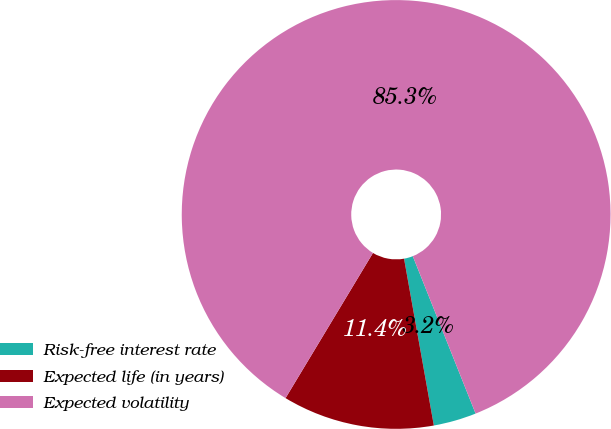Convert chart to OTSL. <chart><loc_0><loc_0><loc_500><loc_500><pie_chart><fcel>Risk-free interest rate<fcel>Expected life (in years)<fcel>Expected volatility<nl><fcel>3.23%<fcel>11.44%<fcel>85.33%<nl></chart> 